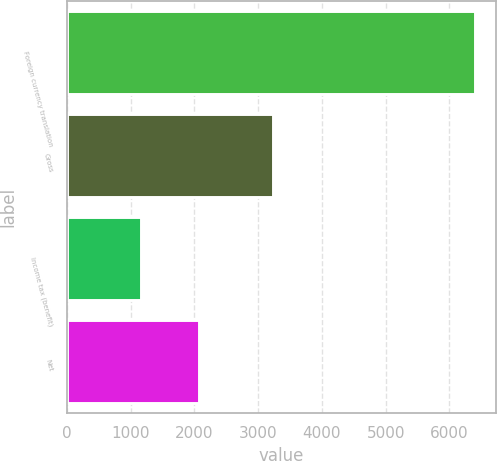<chart> <loc_0><loc_0><loc_500><loc_500><bar_chart><fcel>Foreign currency translation<fcel>Gross<fcel>Income tax (benefit)<fcel>Net<nl><fcel>6407<fcel>3230<fcel>1157<fcel>2073<nl></chart> 